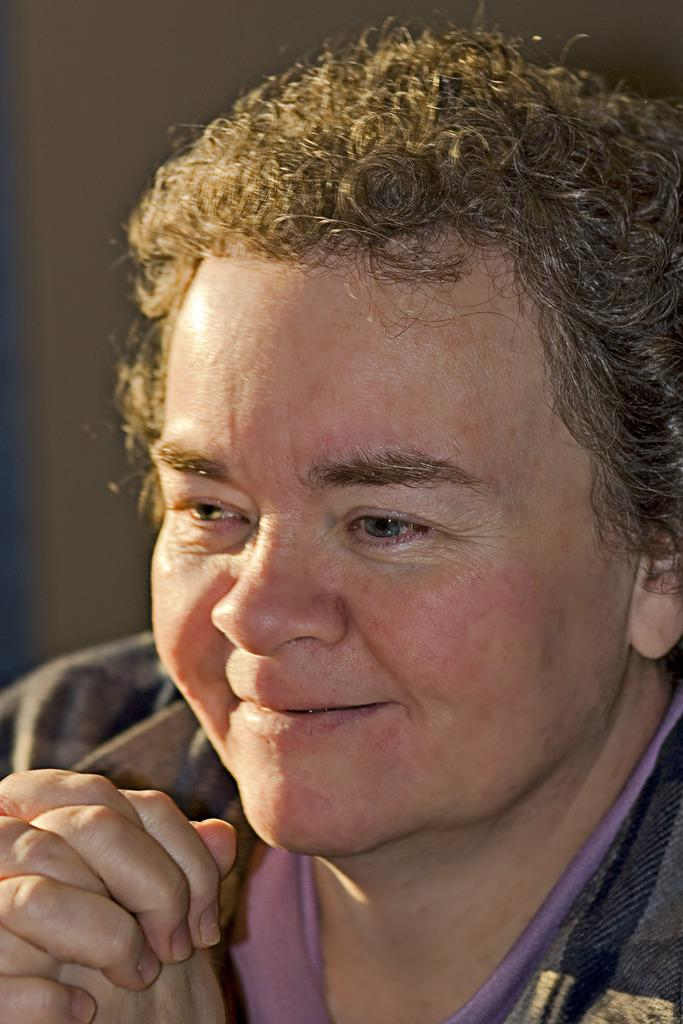What is the main subject of the image? There is a person in the center of the image. What can be seen in the background of the image? There is a wall in the background of the image. What type of cap is the person wearing in the image? There is no cap visible in the image, as the person's head is not shown. 